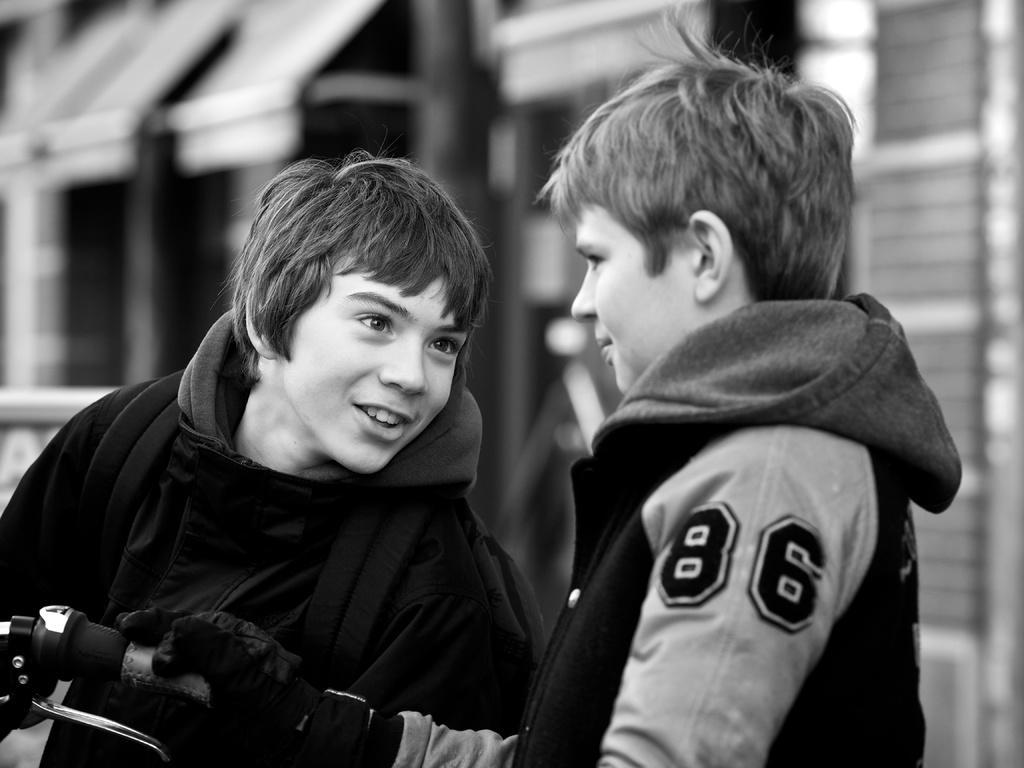How many kids are present in the image? There are two kids standing in the image. What are the kids wearing? The kids are wearing jackets. Can you identify any objects related to transportation in the image? Yes, there is a handle of a bicycle visible in the image. How would you describe the background of the image? The background of the image is blurred. What type of whistle can be heard in the image? There is no whistle present in the image, and therefore no sound can be heard. 